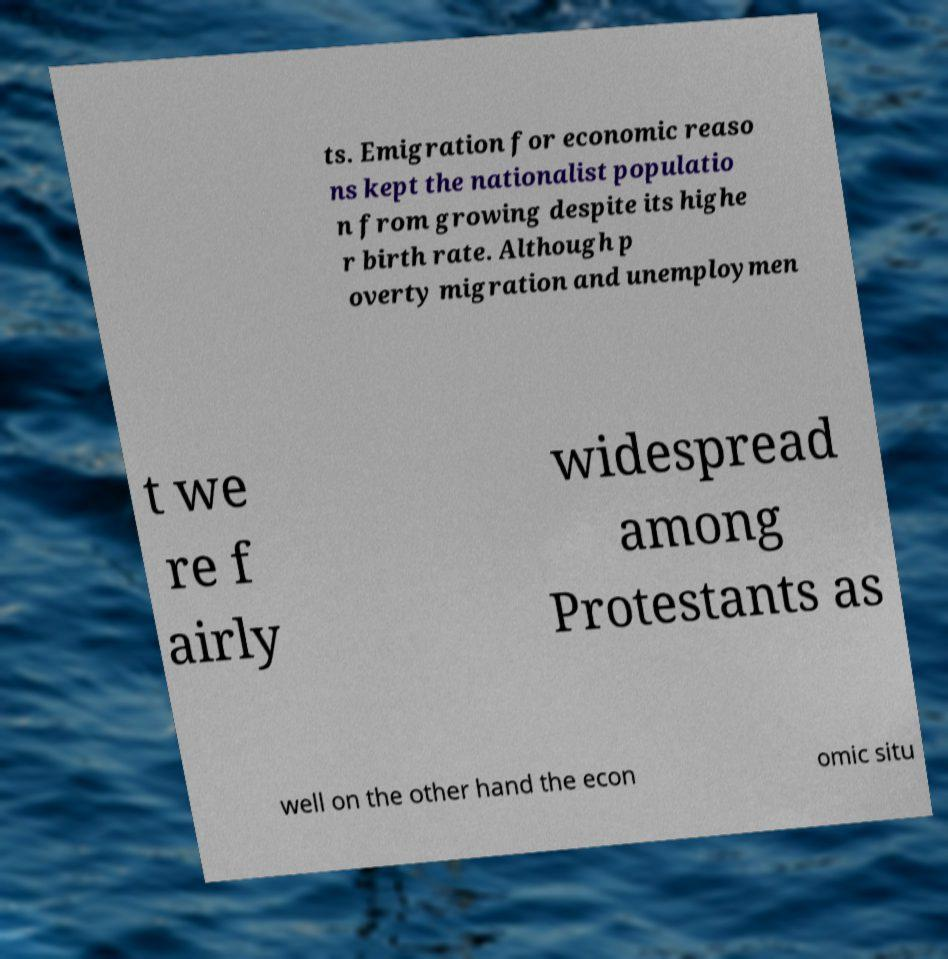For documentation purposes, I need the text within this image transcribed. Could you provide that? ts. Emigration for economic reaso ns kept the nationalist populatio n from growing despite its highe r birth rate. Although p overty migration and unemploymen t we re f airly widespread among Protestants as well on the other hand the econ omic situ 